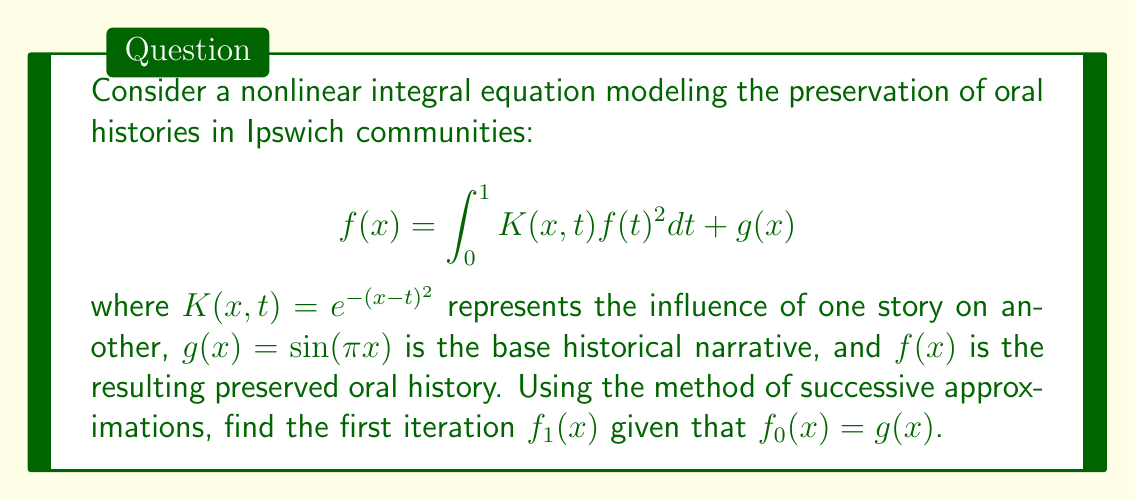Show me your answer to this math problem. To solve this nonlinear integral equation using the method of successive approximations:

1) We start with the initial approximation $f_0(x) = g(x) = \sin(\pi x)$.

2) The first iteration is obtained by substituting $f_0(x)$ into the right-hand side of the equation:

   $$f_1(x) = \int_0^1 K(x,t) [f_0(t)]^2 dt + g(x)$$

3) Substituting the known functions:

   $$f_1(x) = \int_0^1 e^{-(x-t)^2} [\sin(\pi t)]^2 dt + \sin(\pi x)$$

4) The integral can't be evaluated analytically, so we leave it in this form:

   $$f_1(x) = \int_0^1 e^{-(x-t)^2} \sin^2(\pi t) dt + \sin(\pi x)$$

This is the first iteration $f_1(x)$ of the successive approximation method.
Answer: $$f_1(x) = \int_0^1 e^{-(x-t)^2} \sin^2(\pi t) dt + \sin(\pi x)$$ 